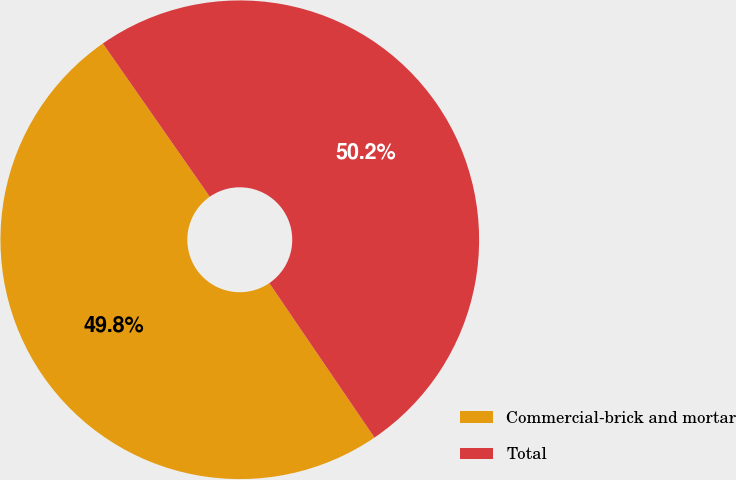Convert chart to OTSL. <chart><loc_0><loc_0><loc_500><loc_500><pie_chart><fcel>Commercial-brick and mortar<fcel>Total<nl><fcel>49.82%<fcel>50.18%<nl></chart> 